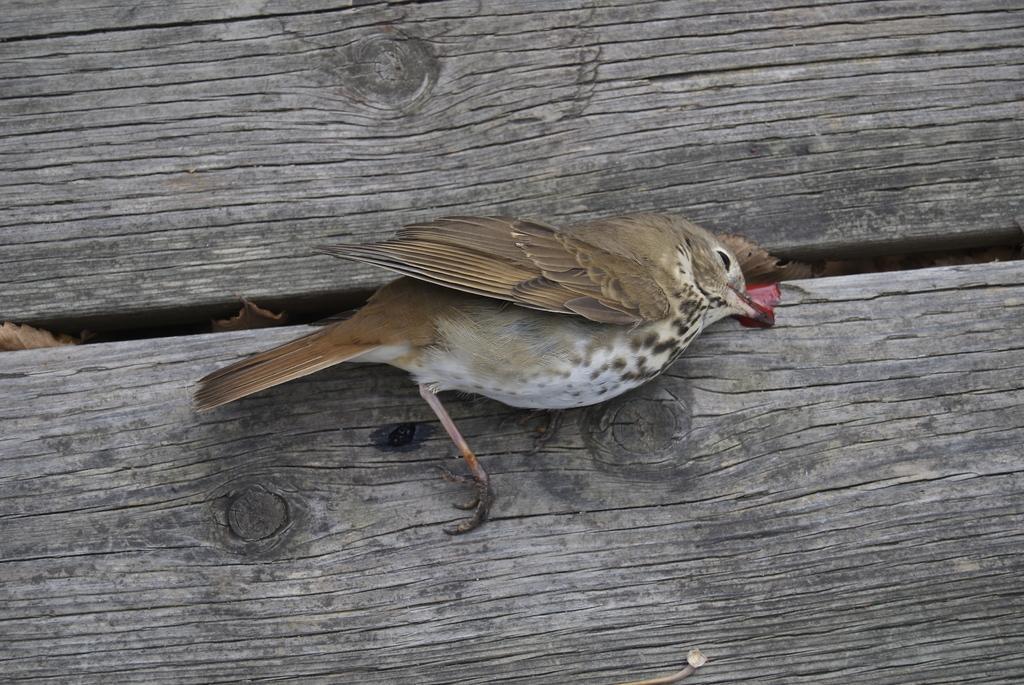Could you give a brief overview of what you see in this image? In the image we can see a bird on the wooden surface. 